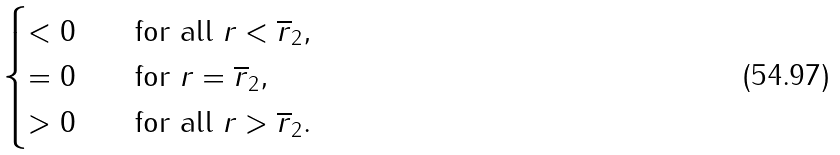Convert formula to latex. <formula><loc_0><loc_0><loc_500><loc_500>\begin{cases} < 0 \quad & \text {for all } r < \overline { r } _ { 2 } , \\ = 0 \quad & \text {for } r = \overline { r } _ { 2 } , \\ > 0 \quad & \text {for all } r > \overline { r } _ { 2 } . \end{cases}</formula> 